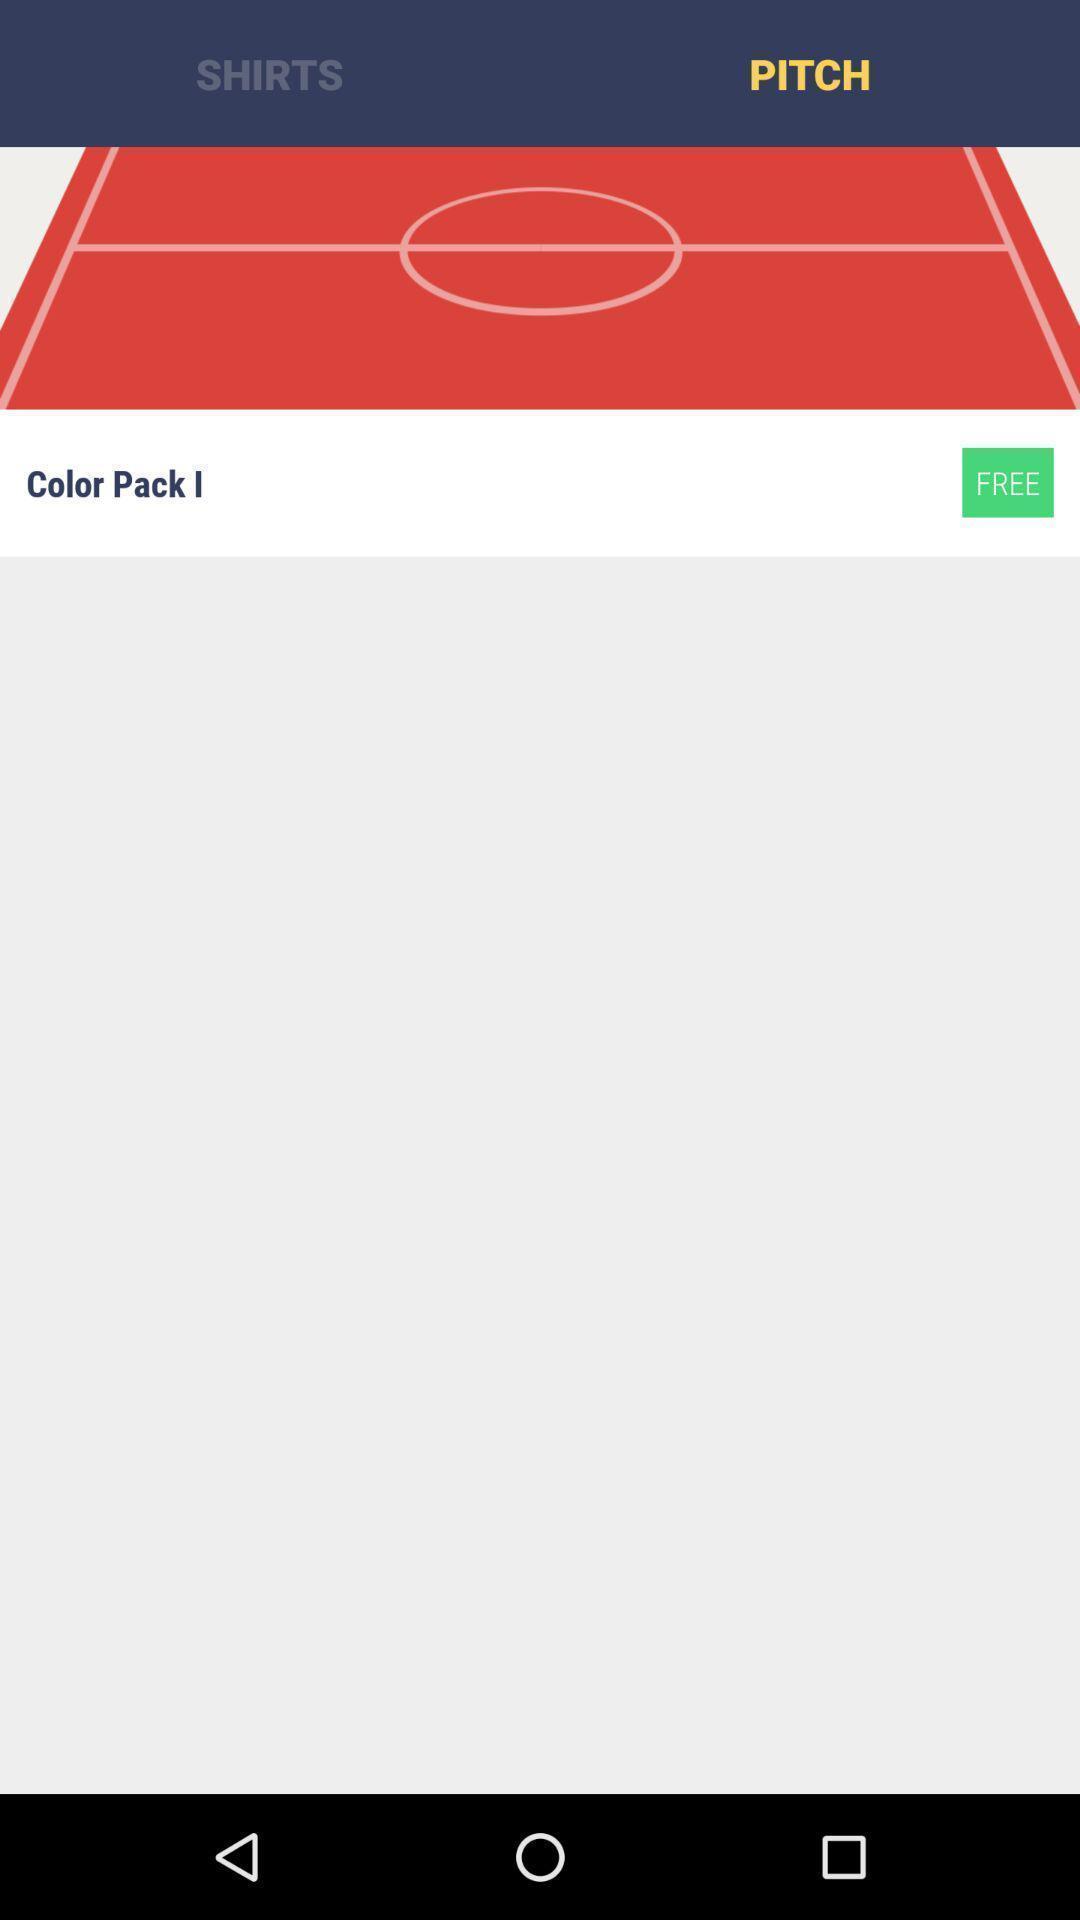What details can you identify in this image? Screen displaying pitch. 